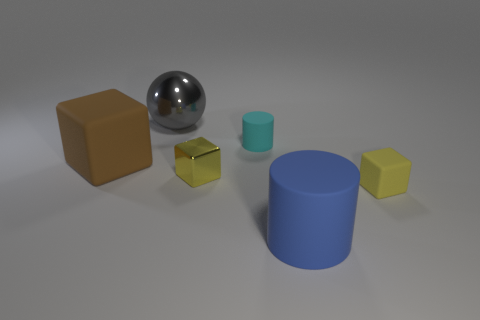There is a ball that is the same size as the blue cylinder; what color is it?
Ensure brevity in your answer.  Gray. How many other tiny rubber things are the same shape as the brown rubber object?
Make the answer very short. 1. What number of balls are either large blue matte objects or cyan things?
Your answer should be compact. 0. Is the shape of the matte object that is on the left side of the large gray object the same as the small rubber object in front of the large brown thing?
Provide a succinct answer. Yes. What material is the brown block?
Make the answer very short. Rubber. What shape is the object that is the same color as the metal cube?
Provide a succinct answer. Cube. How many gray shiny spheres are the same size as the metallic cube?
Offer a terse response. 0. How many objects are either things that are on the right side of the small cyan matte cylinder or tiny matte things that are in front of the big brown matte block?
Give a very brief answer. 2. Do the tiny thing that is in front of the yellow metallic object and the cylinder that is to the right of the tiny cyan cylinder have the same material?
Provide a succinct answer. Yes. There is a tiny matte thing that is in front of the rubber thing that is to the left of the cyan rubber thing; what shape is it?
Give a very brief answer. Cube. 